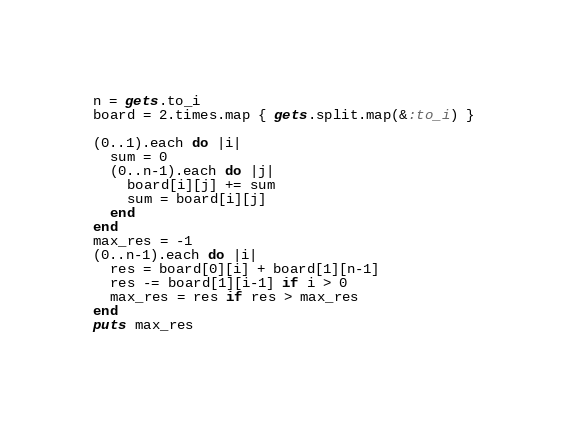<code> <loc_0><loc_0><loc_500><loc_500><_Ruby_>n = gets.to_i
board = 2.times.map { gets.split.map(&:to_i) }

(0..1).each do |i|
  sum = 0
  (0..n-1).each do |j|
    board[i][j] += sum
    sum = board[i][j]
  end
end
max_res = -1
(0..n-1).each do |i|
  res = board[0][i] + board[1][n-1]
  res -= board[1][i-1] if i > 0
  max_res = res if res > max_res
end
puts max_res</code> 